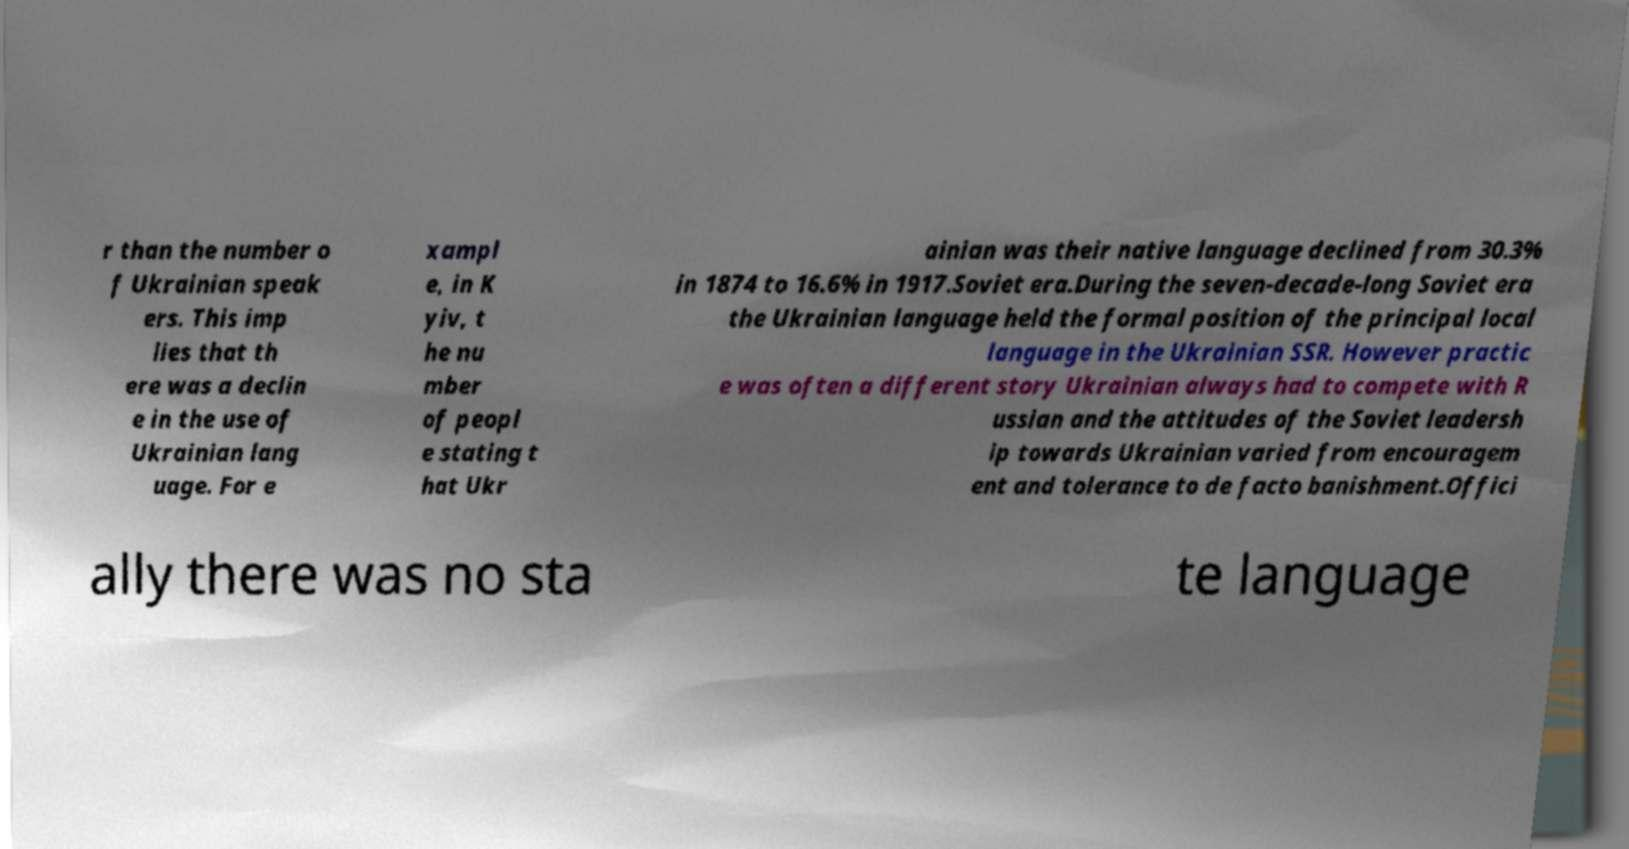Can you read and provide the text displayed in the image?This photo seems to have some interesting text. Can you extract and type it out for me? r than the number o f Ukrainian speak ers. This imp lies that th ere was a declin e in the use of Ukrainian lang uage. For e xampl e, in K yiv, t he nu mber of peopl e stating t hat Ukr ainian was their native language declined from 30.3% in 1874 to 16.6% in 1917.Soviet era.During the seven-decade-long Soviet era the Ukrainian language held the formal position of the principal local language in the Ukrainian SSR. However practic e was often a different story Ukrainian always had to compete with R ussian and the attitudes of the Soviet leadersh ip towards Ukrainian varied from encouragem ent and tolerance to de facto banishment.Offici ally there was no sta te language 